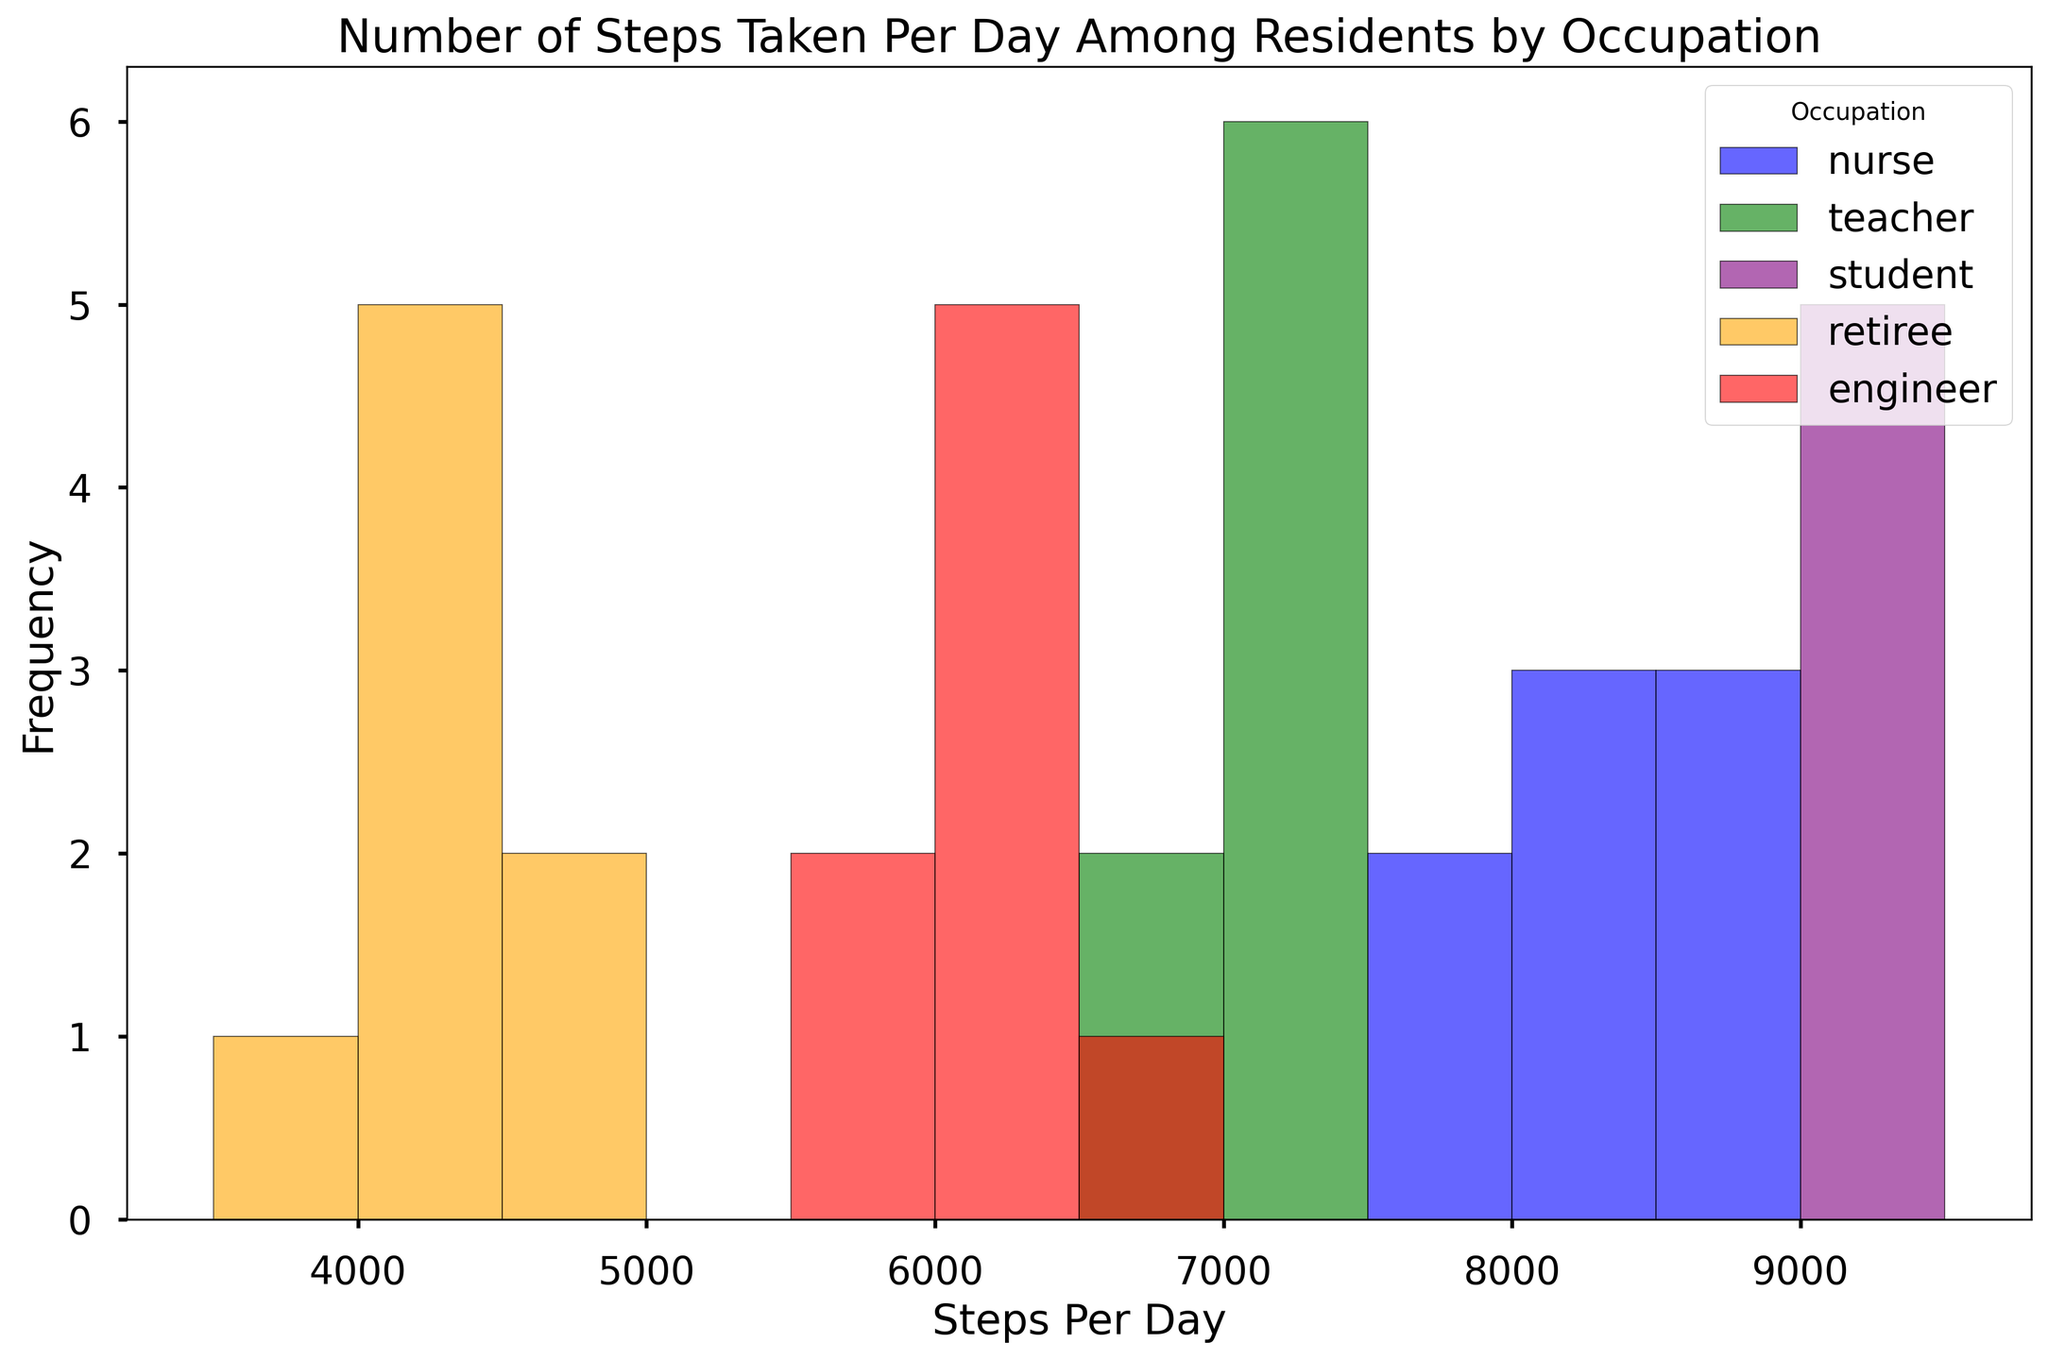What occupation has the highest frequency in the "7500-8000" steps per day bin? The histogram shows the frequency of each occupation in various steps per day bins. By identifying the "7500-8000" bin and comparing the heights of the bars, we can see which occupation has the highest frequency.
Answer: nurse Which occupation has the lowest overall frequency of steps per day? By observing the histogram and comparing the heights of all bars across all bins for each occupation, the one with the smallest cumulative height will have the lowest overall frequency.
Answer: retiree Among the nurses, what is the most common range of steps per day? Look at the distribution of steps for nurses. Identify the bin with the highest bar to determine the most common range.
Answer: 8000-8500 How does the average number of steps per day for students compare to engineers? From the histogram, visually estimate the central tendency for both students and engineers by assessing the peaks of their distributions. Students' data seems centered around higher numbers than the engineers.
Answer: Students generally take more steps per day than engineers Which occupation takes the most steps on average per day? The histogram allows us to see where the central tendency (average) lies for each occupation by comparing the positions of the highest bars for each occupation.
Answer: student What is the range of steps per day covered by the bin with the highest frequency for retirees? Identify the highest bar in the retiree's section and read the range of steps per day it represents from the x-axis.
Answer: 4000-4500 Compare the steps per day distribution between teachers and students. Which has a broader range? By examining the spread of the bars for teachers and students, the broader range occupation will have bars spread across more bins on the x-axis.
Answer: student What is the least common range of steps per day for engineers? Identify the bin with the smallest bar within the engineer's section by comparing the heights of bars.
Answer: 5800-6300 How many bins in the histogram are there between "3500-10000" steps per day? Count the number of intervals on the x-axis that cover the entire range from "3500-10000" steps per day. Each bin represents a certain interval.
Answer: 13 What color bar represents the teacher's step counts in the histogram? Identify the color legend and find the color associated with "teacher".
Answer: green 